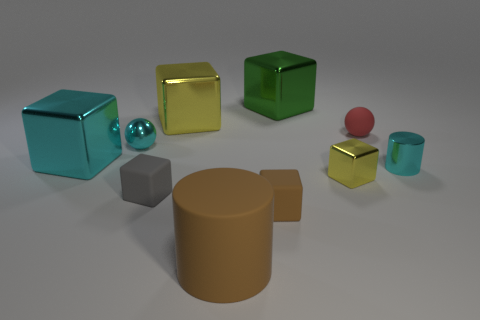There is a green cube that is the same size as the brown cylinder; what is it made of?
Provide a succinct answer. Metal. How many other objects are the same material as the big yellow object?
Provide a succinct answer. 5. Is the number of tiny yellow metal blocks behind the cyan metallic cylinder less than the number of cyan metal spheres?
Ensure brevity in your answer.  Yes. Is the red thing the same shape as the big cyan shiny object?
Ensure brevity in your answer.  No. What is the size of the cyan shiny thing in front of the metal block that is on the left side of the matte object left of the big yellow shiny block?
Provide a short and direct response. Small. There is a brown object that is the same shape as the big yellow thing; what is it made of?
Keep it short and to the point. Rubber. Are there any other things that are the same size as the brown cylinder?
Offer a terse response. Yes. There is a green cube that is behind the large metallic object that is to the left of the small metallic sphere; what size is it?
Your response must be concise. Large. The large matte thing has what color?
Provide a short and direct response. Brown. There is a yellow metal object on the left side of the big green shiny object; how many tiny cubes are on the left side of it?
Your response must be concise. 1. 